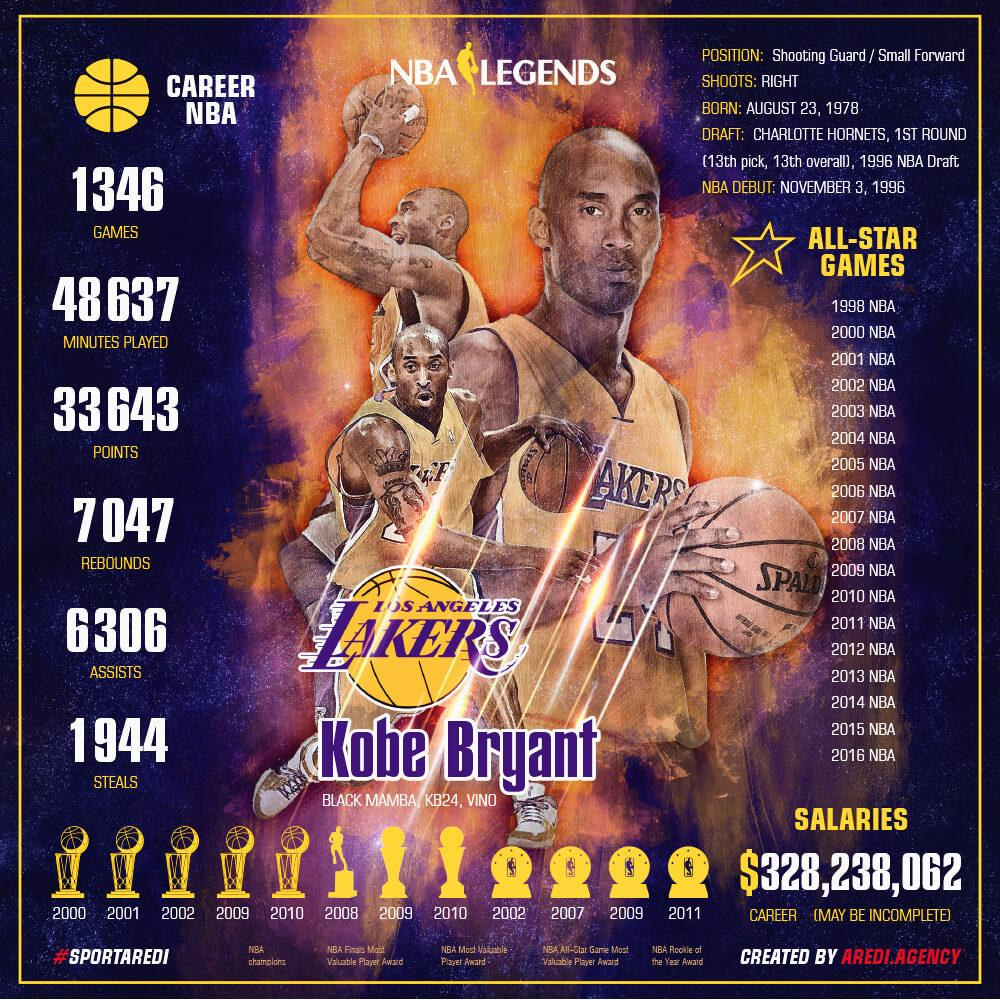Indicate a few pertinent items in this graphic. Kobe Bryant was known by several nicknames, including "Black Mamba," "KB24," and "VINO. Kobe Bryant, at the age of 18, began his illustrious NBA career. Kobe Bryant had a total of 194 steals in his illustrious NBA career, which spanned from 1996 to 2016. As of 2023, Kobe Bryant's total earnings throughout his career amounted to a staggering $328,238,062. Kobe Bryant scored 33643 points during his NBA career. 